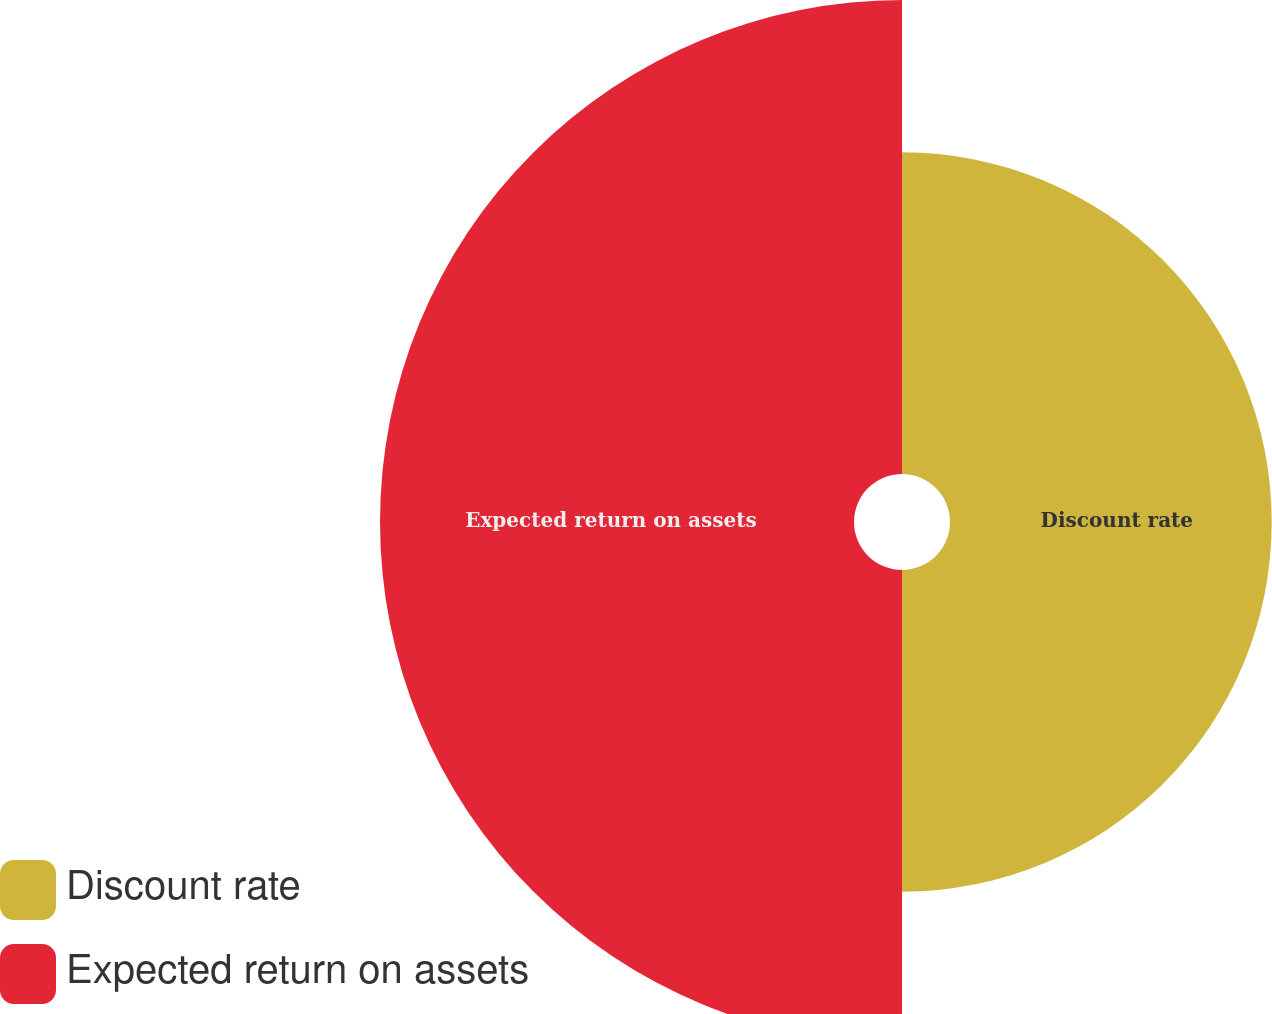Convert chart. <chart><loc_0><loc_0><loc_500><loc_500><pie_chart><fcel>Discount rate<fcel>Expected return on assets<nl><fcel>40.43%<fcel>59.57%<nl></chart> 